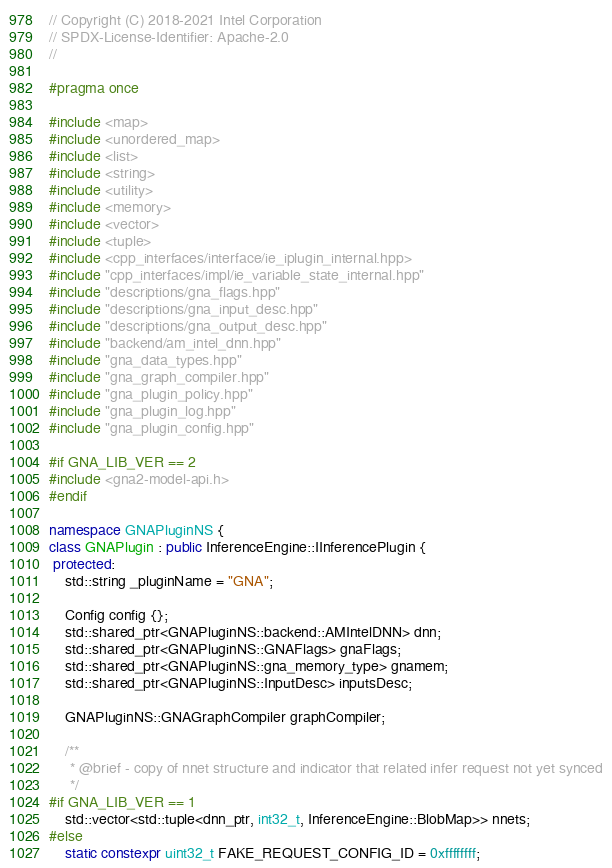Convert code to text. <code><loc_0><loc_0><loc_500><loc_500><_C++_>// Copyright (C) 2018-2021 Intel Corporation
// SPDX-License-Identifier: Apache-2.0
//

#pragma once

#include <map>
#include <unordered_map>
#include <list>
#include <string>
#include <utility>
#include <memory>
#include <vector>
#include <tuple>
#include <cpp_interfaces/interface/ie_iplugin_internal.hpp>
#include "cpp_interfaces/impl/ie_variable_state_internal.hpp"
#include "descriptions/gna_flags.hpp"
#include "descriptions/gna_input_desc.hpp"
#include "descriptions/gna_output_desc.hpp"
#include "backend/am_intel_dnn.hpp"
#include "gna_data_types.hpp"
#include "gna_graph_compiler.hpp"
#include "gna_plugin_policy.hpp"
#include "gna_plugin_log.hpp"
#include "gna_plugin_config.hpp"

#if GNA_LIB_VER == 2
#include <gna2-model-api.h>
#endif

namespace GNAPluginNS {
class GNAPlugin : public InferenceEngine::IInferencePlugin {
 protected:
    std::string _pluginName = "GNA";

    Config config {};
    std::shared_ptr<GNAPluginNS::backend::AMIntelDNN> dnn;
    std::shared_ptr<GNAPluginNS::GNAFlags> gnaFlags;
    std::shared_ptr<GNAPluginNS::gna_memory_type> gnamem;
    std::shared_ptr<GNAPluginNS::InputDesc> inputsDesc;

    GNAPluginNS::GNAGraphCompiler graphCompiler;

    /**
     * @brief - copy of nnet structure and indicator that related infer request not yet synced
     */
#if GNA_LIB_VER == 1
    std::vector<std::tuple<dnn_ptr, int32_t, InferenceEngine::BlobMap>> nnets;
#else
    static constexpr uint32_t FAKE_REQUEST_CONFIG_ID = 0xffffffff;</code> 